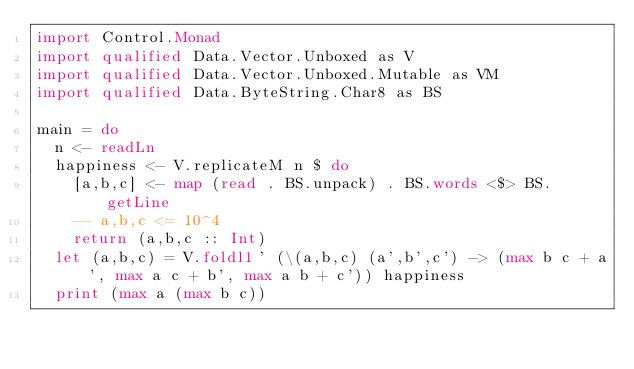<code> <loc_0><loc_0><loc_500><loc_500><_Haskell_>import Control.Monad
import qualified Data.Vector.Unboxed as V
import qualified Data.Vector.Unboxed.Mutable as VM
import qualified Data.ByteString.Char8 as BS

main = do
  n <- readLn
  happiness <- V.replicateM n $ do
    [a,b,c] <- map (read . BS.unpack) . BS.words <$> BS.getLine
    -- a,b,c <= 10^4
    return (a,b,c :: Int)
  let (a,b,c) = V.foldl1' (\(a,b,c) (a',b',c') -> (max b c + a', max a c + b', max a b + c')) happiness
  print (max a (max b c))
</code> 